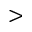<formula> <loc_0><loc_0><loc_500><loc_500>></formula> 